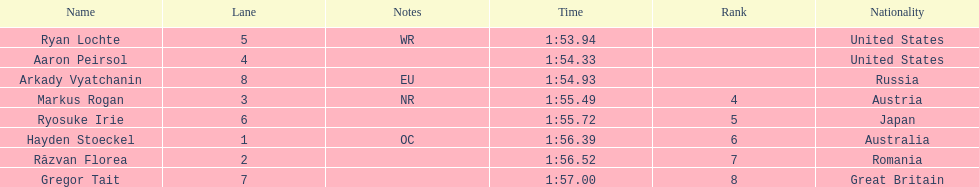Did austria or russia rank higher? Russia. 